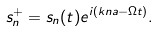<formula> <loc_0><loc_0><loc_500><loc_500>s _ { n } ^ { + } = s _ { n } ( t ) e ^ { i \left ( k n a - \Omega t \right ) } .</formula> 